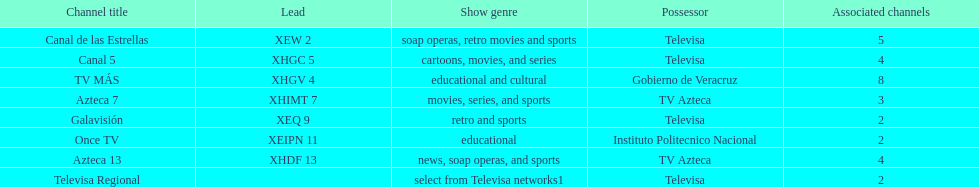Name each of tv azteca's network names. Azteca 7, Azteca 13. 